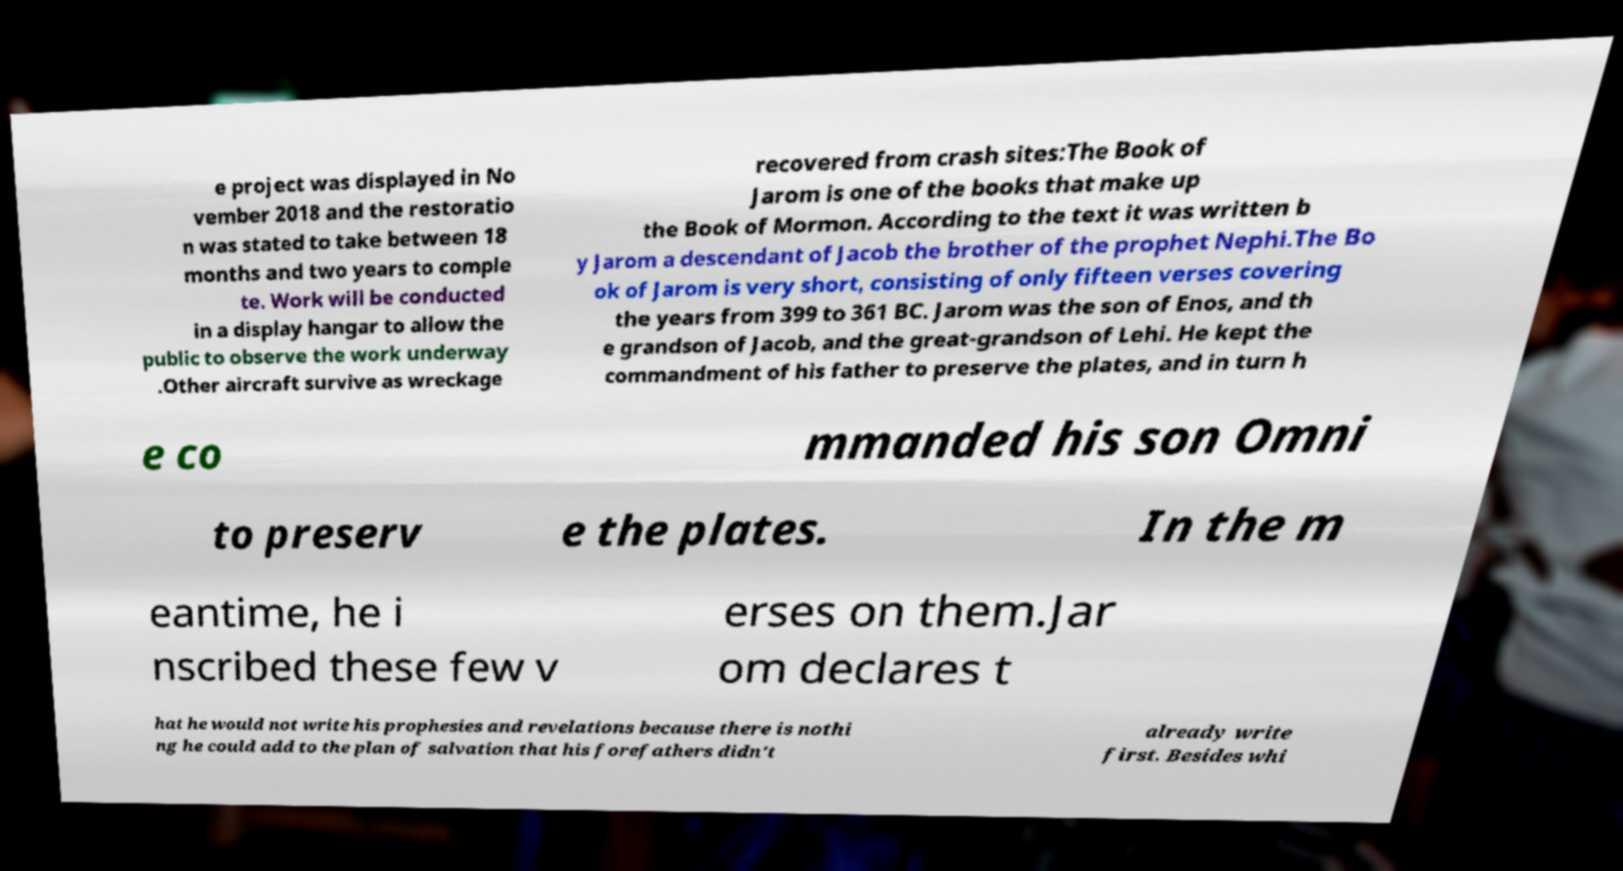Can you accurately transcribe the text from the provided image for me? e project was displayed in No vember 2018 and the restoratio n was stated to take between 18 months and two years to comple te. Work will be conducted in a display hangar to allow the public to observe the work underway .Other aircraft survive as wreckage recovered from crash sites:The Book of Jarom is one of the books that make up the Book of Mormon. According to the text it was written b y Jarom a descendant of Jacob the brother of the prophet Nephi.The Bo ok of Jarom is very short, consisting of only fifteen verses covering the years from 399 to 361 BC. Jarom was the son of Enos, and th e grandson of Jacob, and the great-grandson of Lehi. He kept the commandment of his father to preserve the plates, and in turn h e co mmanded his son Omni to preserv e the plates. In the m eantime, he i nscribed these few v erses on them.Jar om declares t hat he would not write his prophesies and revelations because there is nothi ng he could add to the plan of salvation that his forefathers didn't already write first. Besides whi 